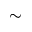Convert formula to latex. <formula><loc_0><loc_0><loc_500><loc_500>\sim</formula> 